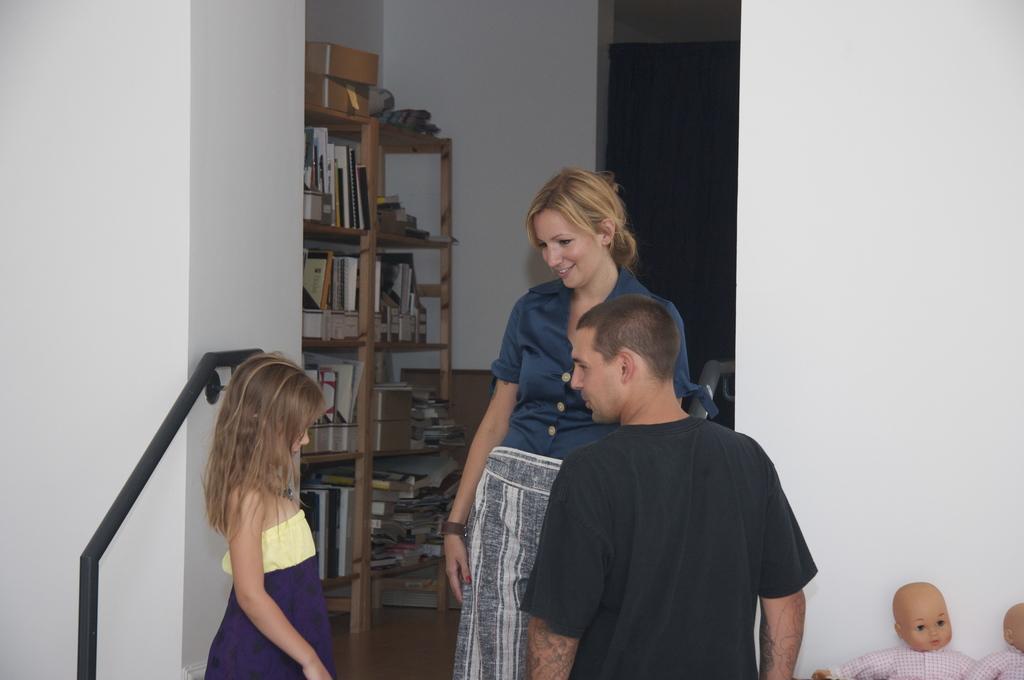Please provide a concise description of this image. This picture seems to be clicked inside the room. On the right corner we can see the dolls. In the center we can see a person wearing black color dress and standing and we can see a woman wearing blue color shirt, smiling and standing and we can see a girl standing. On the left corner we can see a black color metal rod. In the background we can see the wall, wooden rack containing books and many other objects. 